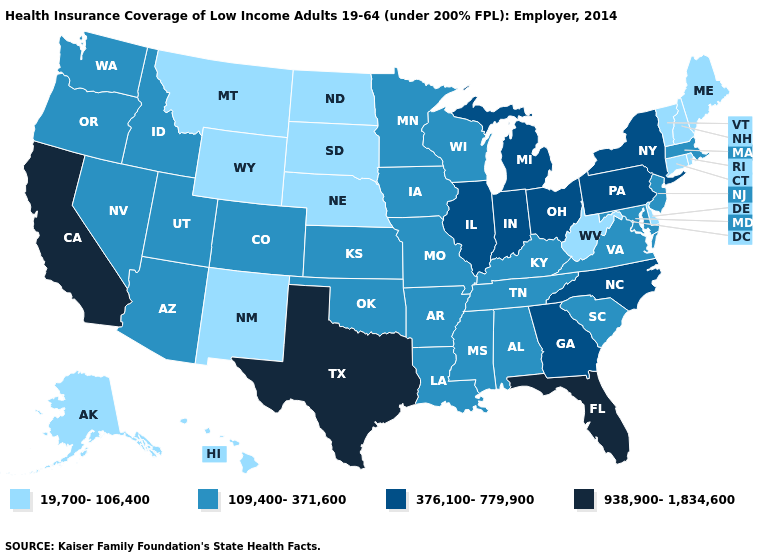Does North Dakota have a lower value than New York?
Quick response, please. Yes. What is the value of Nebraska?
Concise answer only. 19,700-106,400. Name the states that have a value in the range 19,700-106,400?
Write a very short answer. Alaska, Connecticut, Delaware, Hawaii, Maine, Montana, Nebraska, New Hampshire, New Mexico, North Dakota, Rhode Island, South Dakota, Vermont, West Virginia, Wyoming. Which states have the lowest value in the USA?
Keep it brief. Alaska, Connecticut, Delaware, Hawaii, Maine, Montana, Nebraska, New Hampshire, New Mexico, North Dakota, Rhode Island, South Dakota, Vermont, West Virginia, Wyoming. Is the legend a continuous bar?
Answer briefly. No. How many symbols are there in the legend?
Concise answer only. 4. What is the highest value in the MidWest ?
Concise answer only. 376,100-779,900. Does Maine have the lowest value in the Northeast?
Keep it brief. Yes. Name the states that have a value in the range 19,700-106,400?
Concise answer only. Alaska, Connecticut, Delaware, Hawaii, Maine, Montana, Nebraska, New Hampshire, New Mexico, North Dakota, Rhode Island, South Dakota, Vermont, West Virginia, Wyoming. What is the value of California?
Be succinct. 938,900-1,834,600. Name the states that have a value in the range 109,400-371,600?
Be succinct. Alabama, Arizona, Arkansas, Colorado, Idaho, Iowa, Kansas, Kentucky, Louisiana, Maryland, Massachusetts, Minnesota, Mississippi, Missouri, Nevada, New Jersey, Oklahoma, Oregon, South Carolina, Tennessee, Utah, Virginia, Washington, Wisconsin. Does Virginia have the same value as New Jersey?
Concise answer only. Yes. Name the states that have a value in the range 376,100-779,900?
Answer briefly. Georgia, Illinois, Indiana, Michigan, New York, North Carolina, Ohio, Pennsylvania. What is the value of Montana?
Give a very brief answer. 19,700-106,400. 